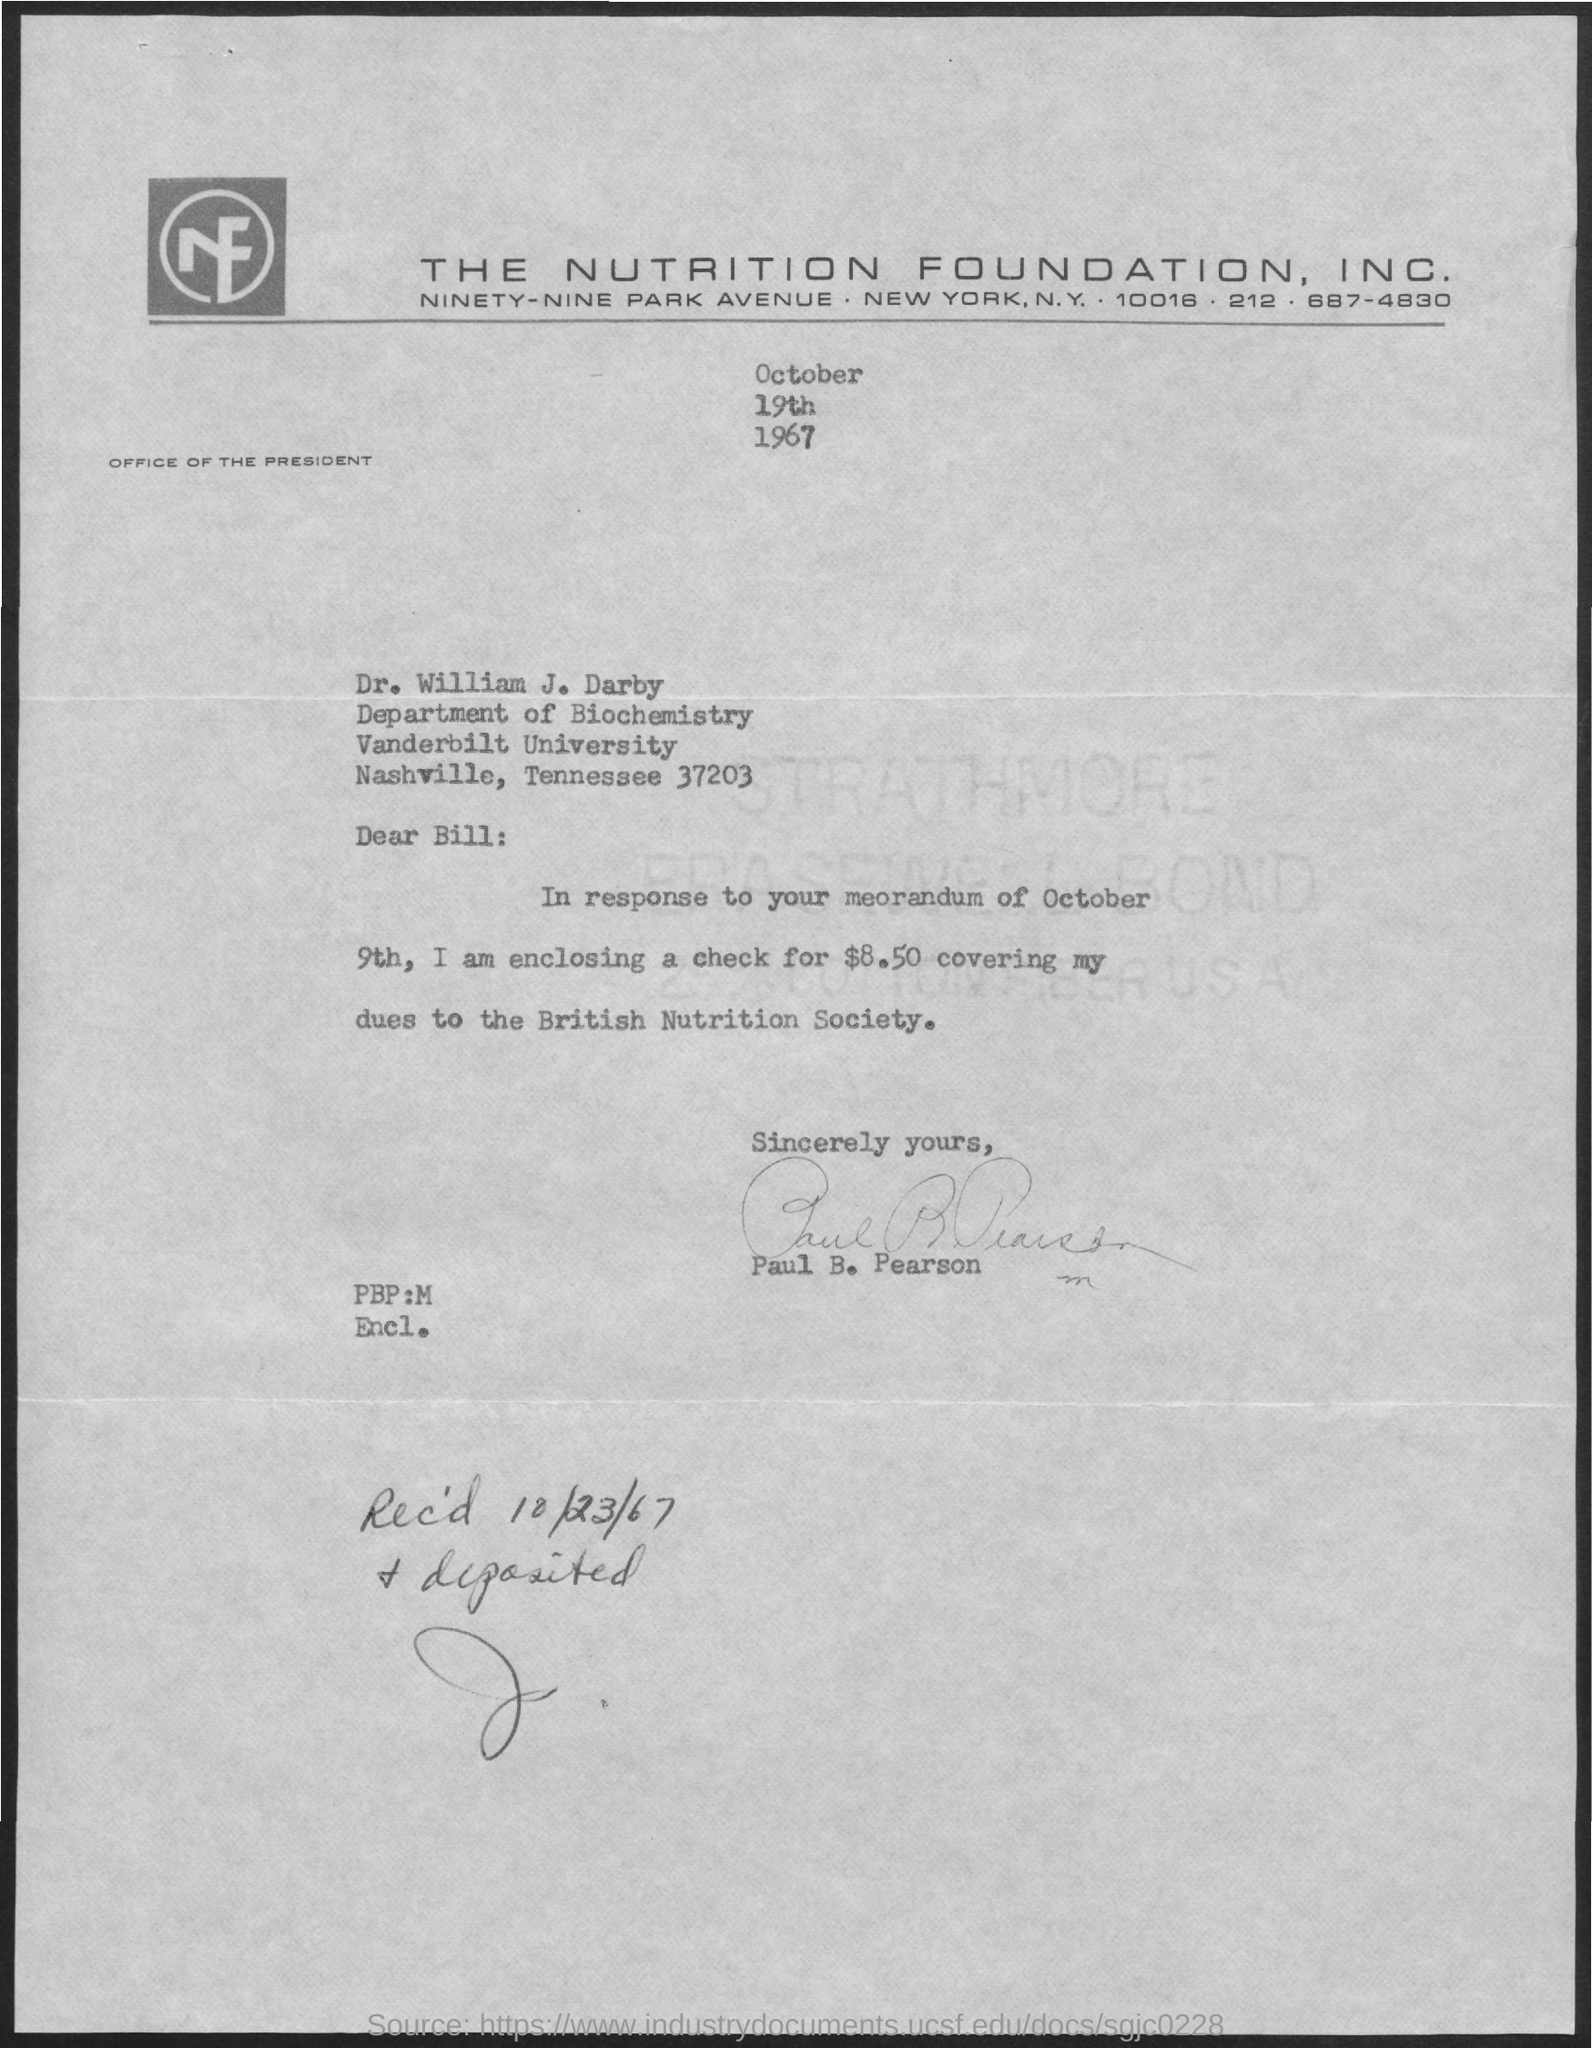What is the date on the document?
Offer a terse response. October 19th 1967. To Whom is this letter addressed to?
Provide a short and direct response. Dr. William J. Darby. Which memorandum's response is in the letter?
Make the answer very short. Memorandum of october 9th. What is the amount in the check that is enclosed?
Your answer should be very brief. $8.50. Who is this letter from?
Your response must be concise. Paul b. Pearson. When was it Received and deposited?
Your response must be concise. 10/23/67. 